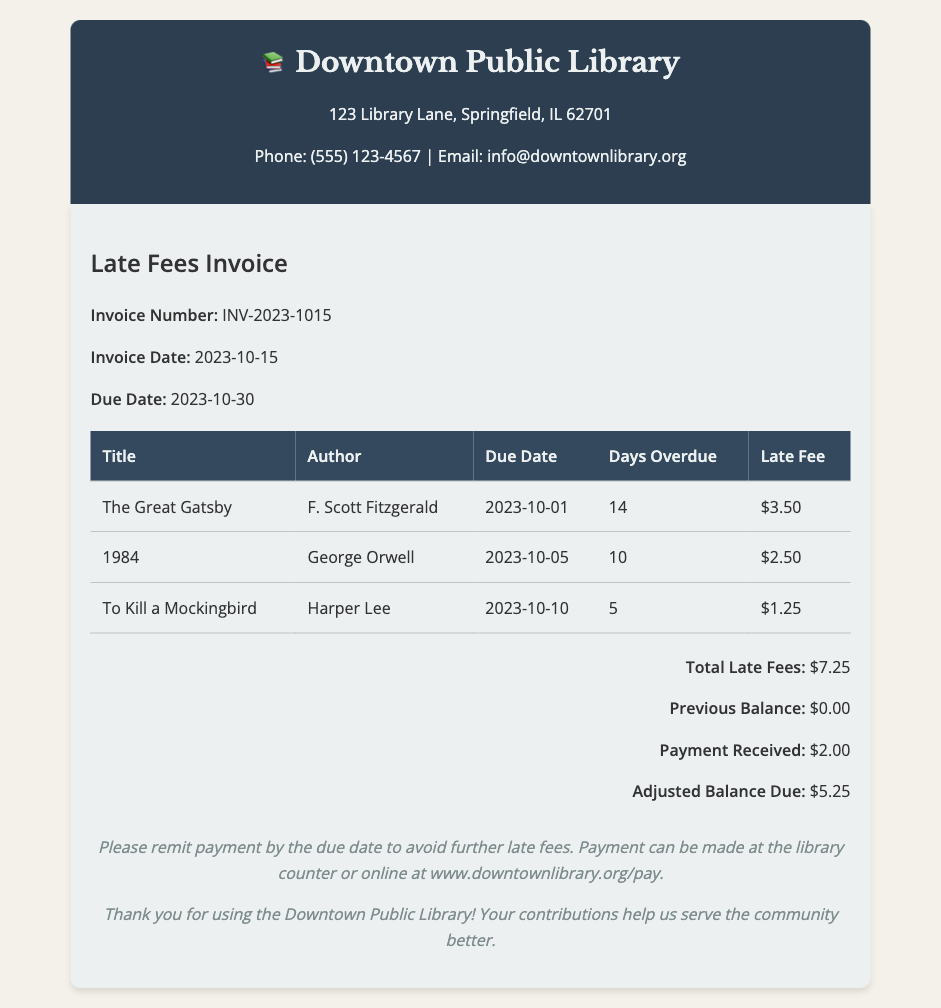What is the invoice number? The invoice number is provided in the document's details section.
Answer: INV-2023-1015 What is the due date for the invoice? The due date is specified next to the due date label in the invoice details.
Answer: 2023-10-30 How much is the total late fee? The total late fee can be found in the totals section of the document.
Answer: $7.25 How many days overdue is "The Great Gatsby"? The number of days overdue is listed in the table for that specific item.
Answer: 14 What payment was received? The document includes a line for payment received among the totals.
Answer: $2.00 What is the adjusted balance due? The adjusted balance due is calculated and listed in the totals section of the document.
Answer: $5.25 Which author wrote "1984"? The author information is included in the table alongside the book title.
Answer: George Orwell How many books are listed in the invoice? The number of items in the table corresponds to the number of books overdue.
Answer: 3 What should be done to avoid further late fees? The document advises what to do in order to avoid further fees in the footer section.
Answer: Remit payment by the due date 